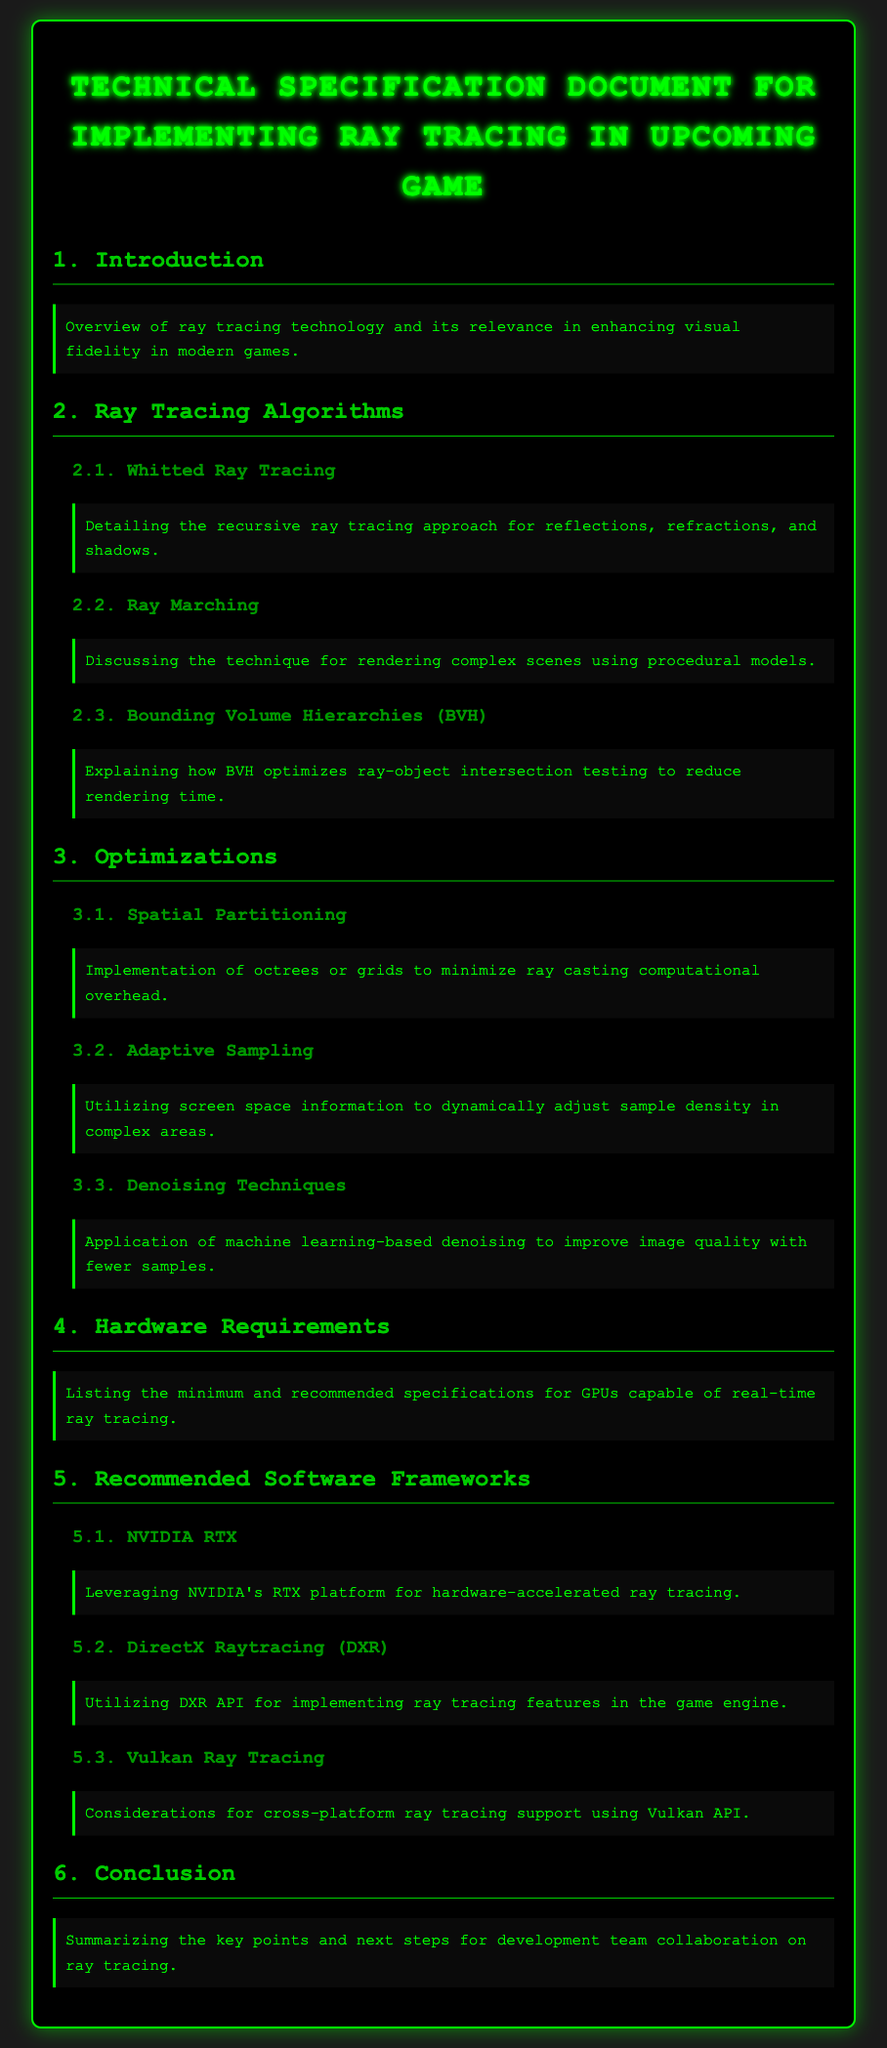What is the title of the document? The title of the document is stated at the beginning, "Technical Specification Document for Implementing Ray Tracing in Upcoming Game."
Answer: Technical Specification Document for Implementing Ray Tracing in Upcoming Game Which algorithm is detailed in section 2.1? Section 2.1 discusses a specific algorithm related to ray tracing, identified as "Whitted Ray Tracing."
Answer: Whitted Ray Tracing What optimization technique is mentioned in section 3.2? Section 3.2 describes a method focusing on dynamically adjusting sample density as "Adaptive Sampling."
Answer: Adaptive Sampling What is a key hardware requirement mentioned in section 4? Section 4 lists the overall need for GPUs that can handle real-time ray tracing but does not give specific hardware.
Answer: GPUs capable of real-time ray tracing Which framework is recommended for hardware-accelerated ray tracing? In section 5.1, it specifies a preferred framework, namely "NVIDIA RTX."
Answer: NVIDIA RTX What does BVH stand for in section 2.3? In section 2.3, BVH refers to "Bounding Volume Hierarchies," which is a critical concept for optimization in ray tracing.
Answer: Bounding Volume Hierarchies What are the denoising techniques referred to in section 3.3? Section 3.3 mentions using "machine learning-based denoising" to enhance image quality.
Answer: machine learning-based denoising What is the goal of ray tracing technology as described in the introduction? The document states that the goal of ray tracing technology is to "enhance visual fidelity in modern games."
Answer: enhance visual fidelity in modern games 